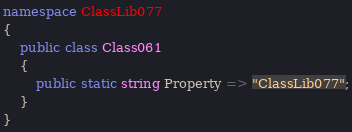<code> <loc_0><loc_0><loc_500><loc_500><_C#_>namespace ClassLib077
{
    public class Class061
    {
        public static string Property => "ClassLib077";
    }
}
</code> 